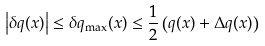<formula> <loc_0><loc_0><loc_500><loc_500>\left | \delta q ( x ) \right | \leq \delta q _ { \max } ( x ) \leq \frac { 1 } { 2 } \left ( q ( x ) + \Delta q ( x ) \right )</formula> 